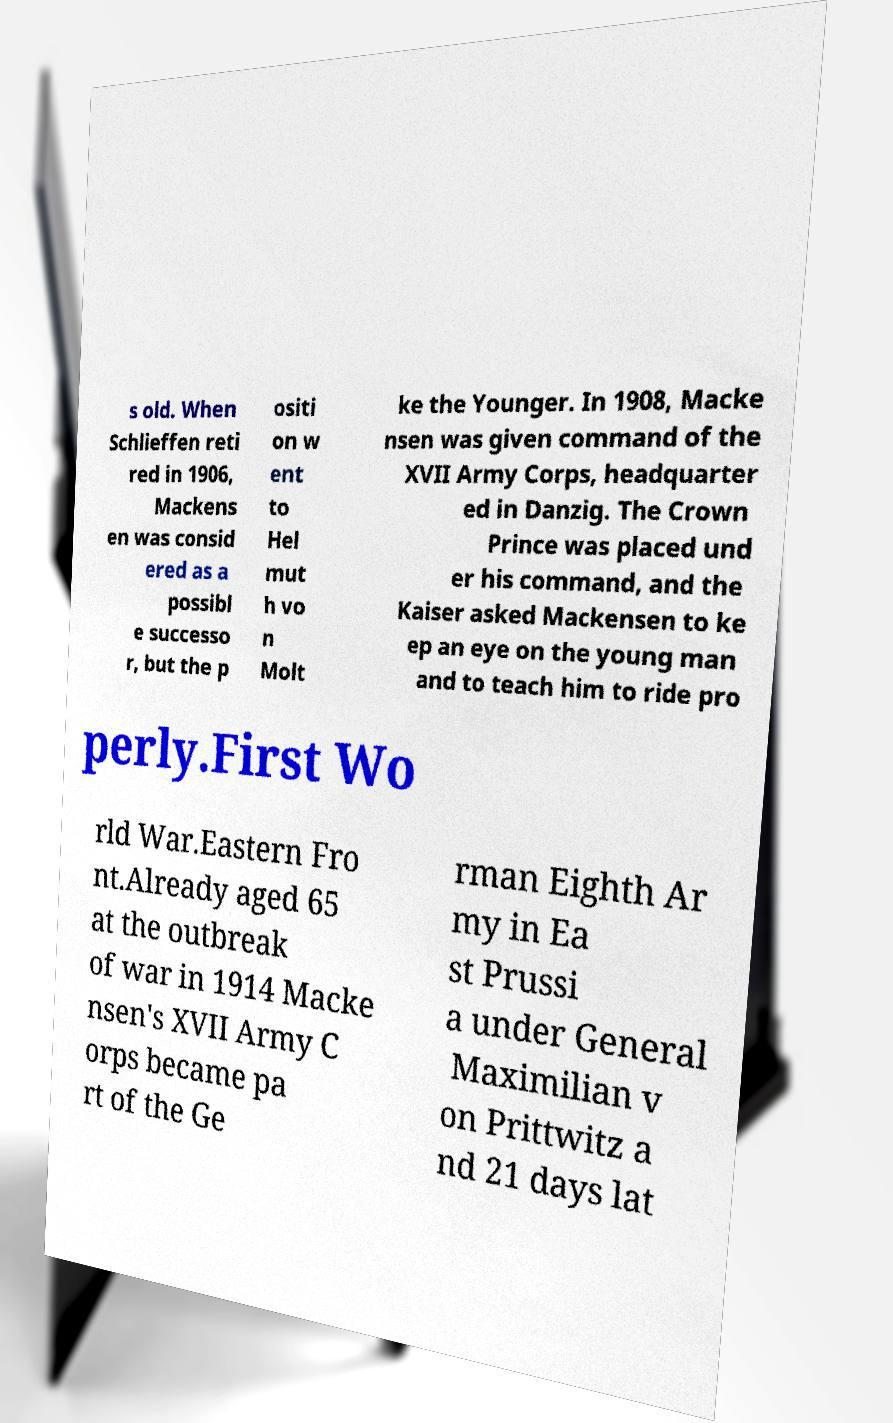What messages or text are displayed in this image? I need them in a readable, typed format. s old. When Schlieffen reti red in 1906, Mackens en was consid ered as a possibl e successo r, but the p ositi on w ent to Hel mut h vo n Molt ke the Younger. In 1908, Macke nsen was given command of the XVII Army Corps, headquarter ed in Danzig. The Crown Prince was placed und er his command, and the Kaiser asked Mackensen to ke ep an eye on the young man and to teach him to ride pro perly.First Wo rld War.Eastern Fro nt.Already aged 65 at the outbreak of war in 1914 Macke nsen's XVII Army C orps became pa rt of the Ge rman Eighth Ar my in Ea st Prussi a under General Maximilian v on Prittwitz a nd 21 days lat 